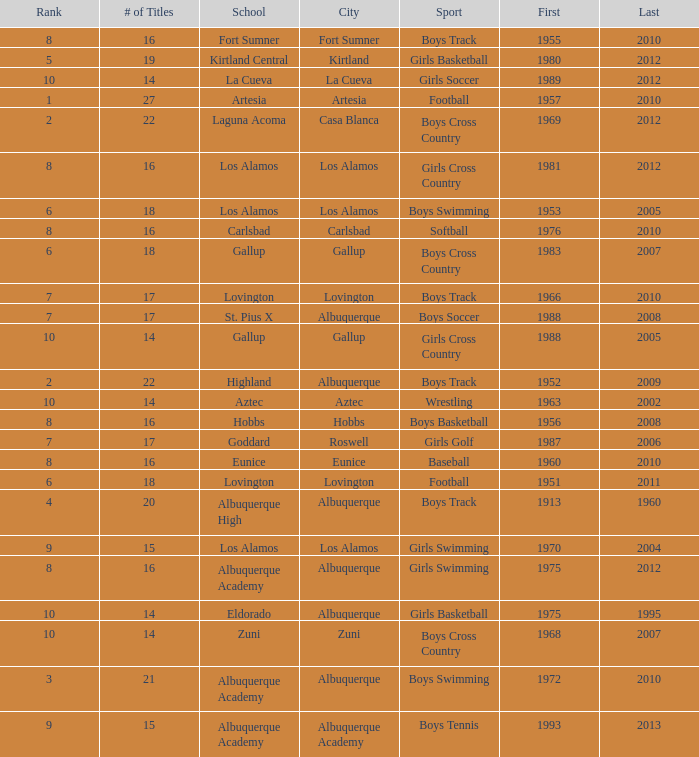What city is the school that had less than 17 titles in boys basketball with the last title being after 2005? Hobbs. 